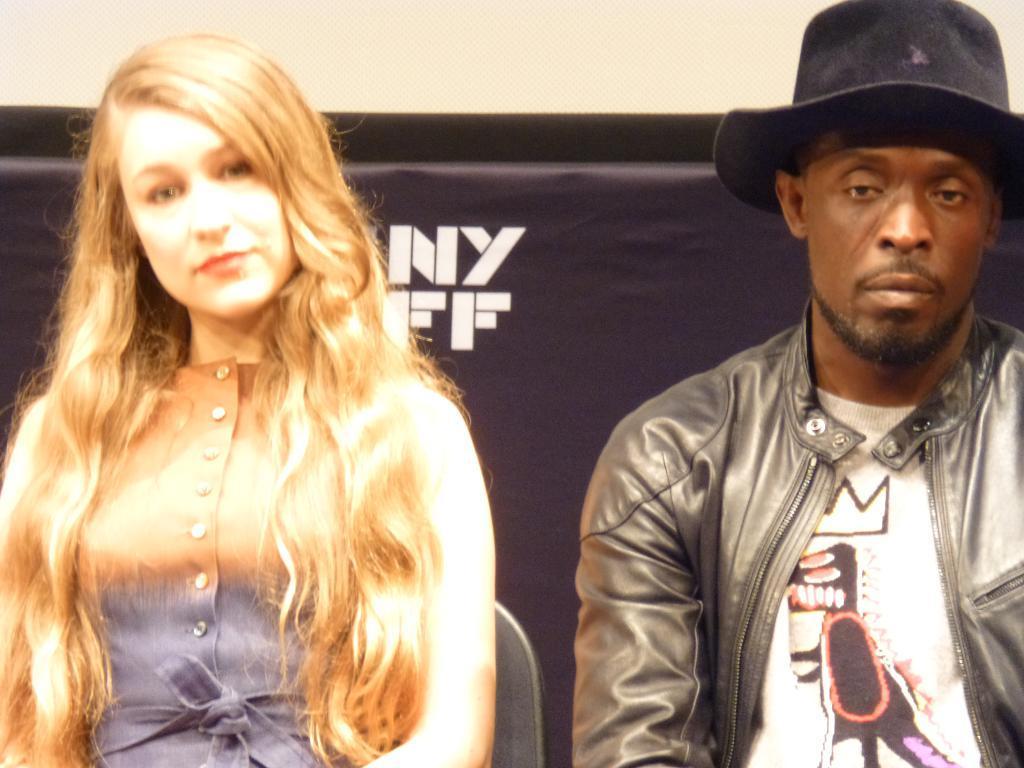Please provide a concise description of this image. In this image I can see two persons. And in the background it looks like a banner or a board. 